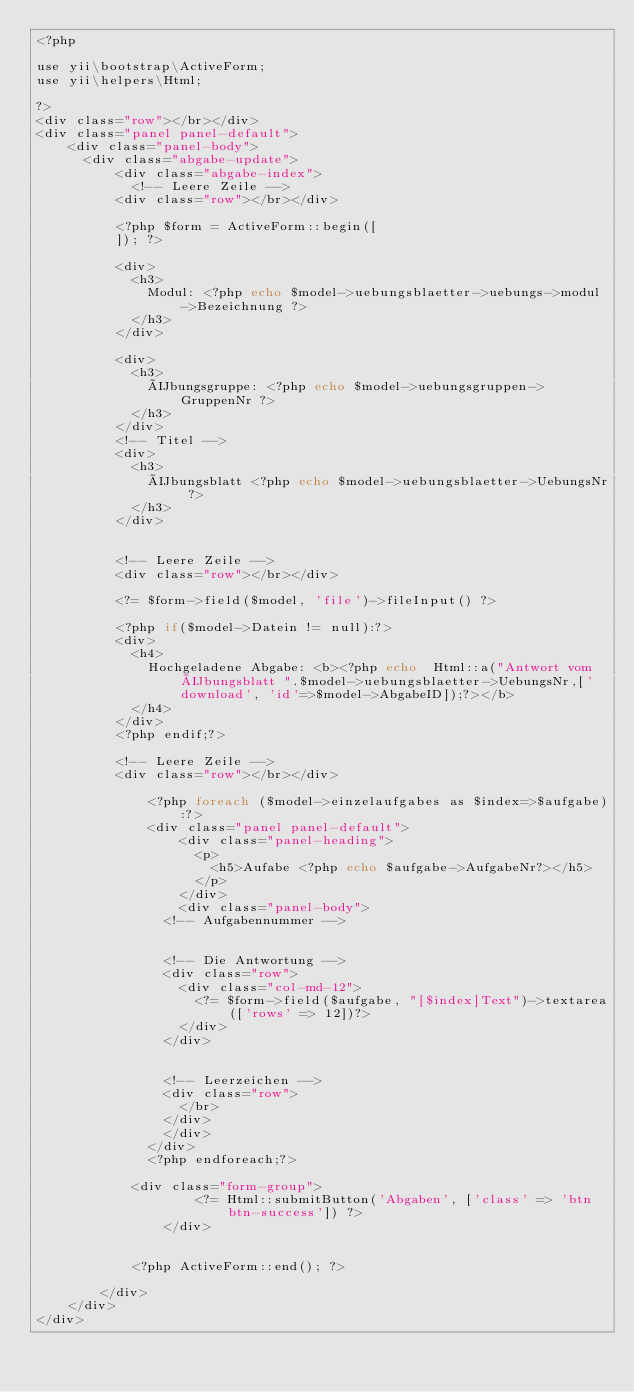<code> <loc_0><loc_0><loc_500><loc_500><_PHP_><?php 

use yii\bootstrap\ActiveForm;
use yii\helpers\Html;

?>
<div class="row"></br></div>
<div class="panel panel-default">
    <div class="panel-body">
    	<div class="abgabe-update">
        	<div class="abgabe-index">
            <!-- Leere Zeile -->
        	<div class="row"></br></div>
        	
        	<?php $form = ActiveForm::begin([
        	]); ?>
        	
        	<div>
        		<h3>
        			Modul: <?php echo $model->uebungsblaetter->uebungs->modul->Bezeichnung ?>
        		</h3>
        	</div>
        	
        	<div>
        		<h3>
        			Übungsgruppe: <?php echo $model->uebungsgruppen->GruppenNr ?>
        		</h3>
        	</div>
        	<!-- Titel -->
        	<div>
        		<h3>
        			Übungsblatt <?php echo $model->uebungsblaetter->UebungsNr ?>
        		</h3>
        	</div>
        	
        	
        	<!-- Leere Zeile -->
        	<div class="row"></br></div>
        	
        	<?= $form->field($model, 'file')->fileInput() ?>
        	
        	<?php if($model->Datein != null):?>
        	<div>
        		<h4>
        			Hochgeladene Abgabe: <b><?php echo  Html::a("Antwort vom Übungsblatt ".$model->uebungsblaetter->UebungsNr,['download', 'id'=>$model->AbgabeID]);?></b>
        		</h4>
        	</div>
        	<?php endif;?>
        	
        	<!-- Leere Zeile -->
        	<div class="row"></br></div>	
            	
            	<?php foreach ($model->einzelaufgabes as $index=>$aufgabe):?>
            	<div class="panel panel-default">
                	<div class="panel-heading">
                		<p>
                			<h5>Aufabe <?php echo $aufgabe->AufgabeNr?></h5>
                		</p>
                	</div>
                	<div class="panel-body">
            		<!-- Aufgabennummer -->
            		
            		
            		<!-- Die Antwortung -->
            		<div class="row">
            			<div class="col-md-12">
            				<?= $form->field($aufgabe, "[$index]Text")->textarea(['rows' => 12])?>
            			</div>
            		</div>
            		
            		
            		<!-- Leerzeichen -->
            		<div class="row">
            			</br>
            		</div>
            		</div>
            	</div>
            	<?php endforeach;?>
        		
        		<div class="form-group">
                    <?= Html::submitButton('Abgaben', ['class' => 'btn btn-success']) ?>
                </div>
               
        
            <?php ActiveForm::end(); ?>
        		
        </div>
    </div>
</div></code> 